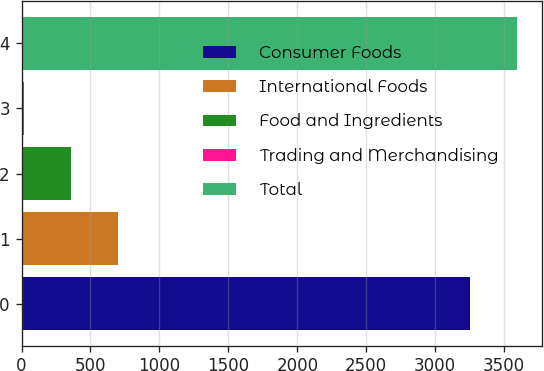<chart> <loc_0><loc_0><loc_500><loc_500><bar_chart><fcel>Consumer Foods<fcel>International Foods<fcel>Food and Ingredients<fcel>Trading and Merchandising<fcel>Total<nl><fcel>3253<fcel>701.84<fcel>358.87<fcel>15.9<fcel>3595.97<nl></chart> 